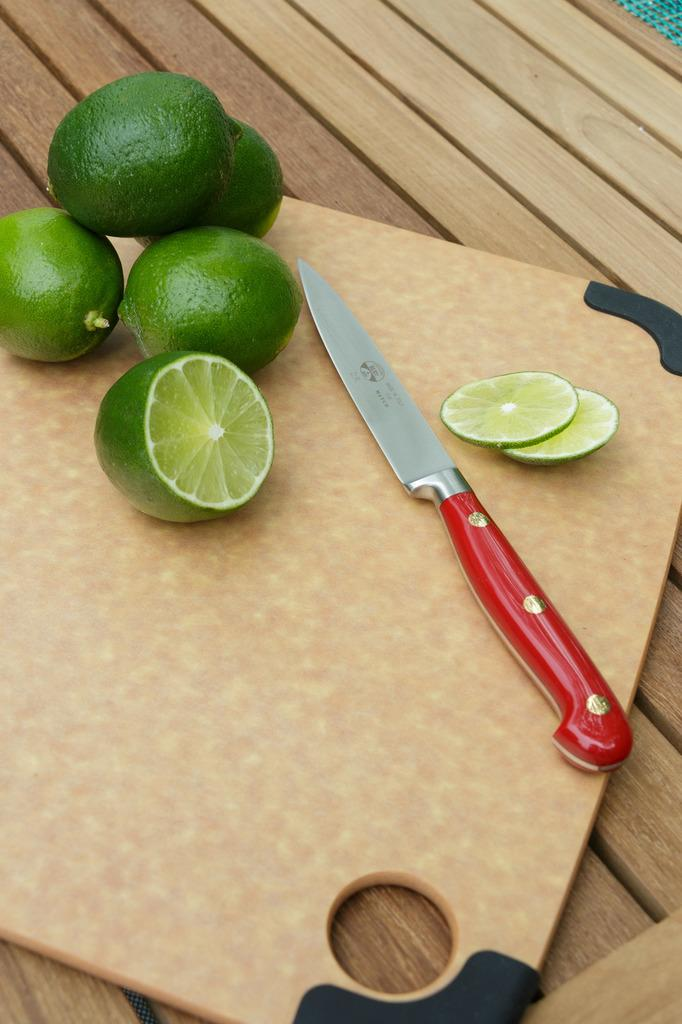What type of fruit is present in the image? There are lemons in the image. How are the lemons presented in the image? There are lemon pieces in the image. What tool is visible in the image? There is a knife in the image. Where is the knife located in the image? The knife is on the table. What surface is the knife placed on? There is a plate on the table. What type of corn can be seen growing in the image? There is no corn present in the image; it features lemons and a knife. How does the person's breath affect the lemons in the image? There is no person present in the image, so their breath cannot affect the lemons. 